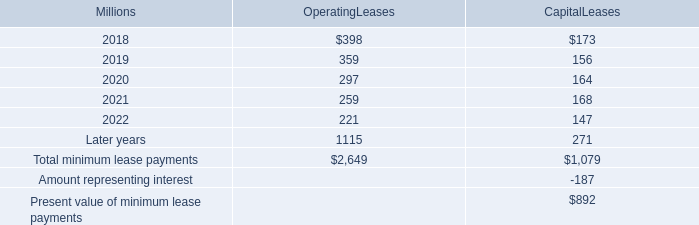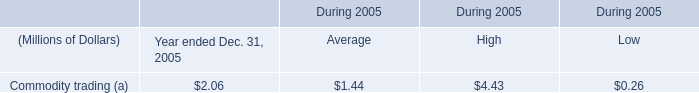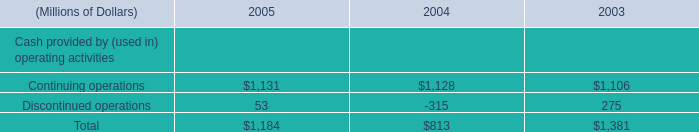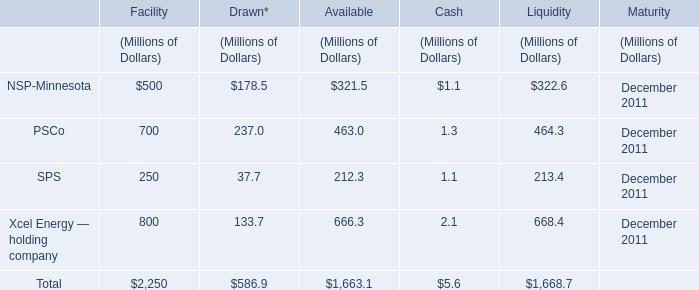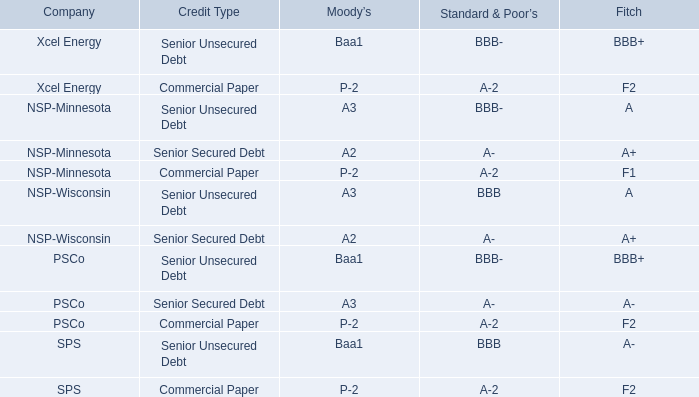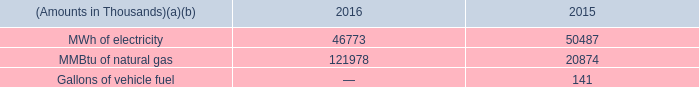what's the total amount of Continuing operations of 2003, MMBtu of natural gas of 2016, and Total of 2005 ? 
Computations: ((1106.0 + 121978.0) + 1184.0)
Answer: 124268.0. 